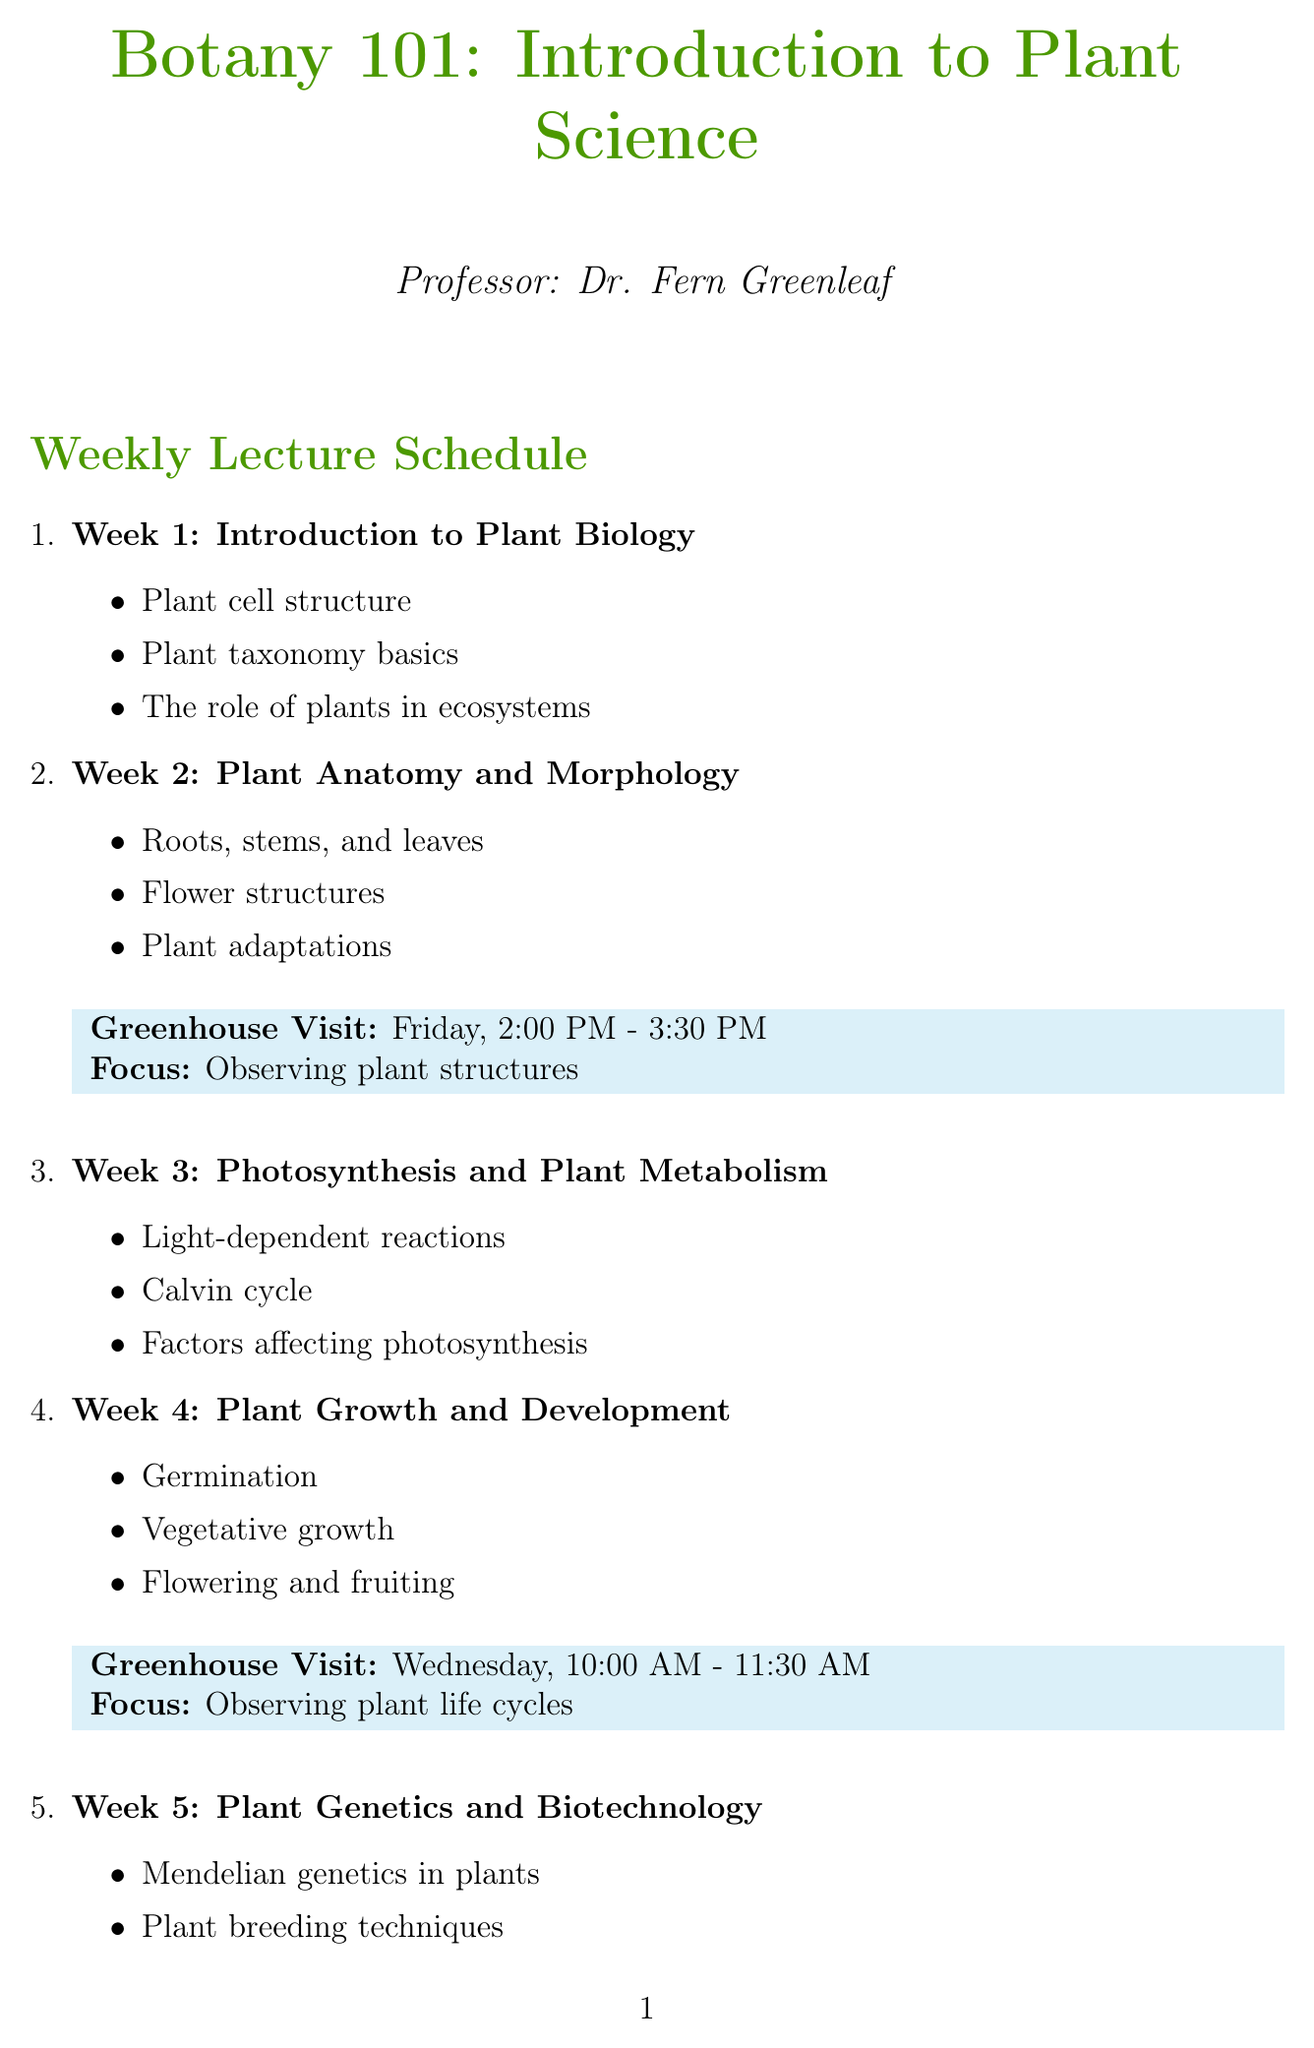What is the focus of the Week 2 greenhouse visit? The greenhouse visit in Week 2 focuses on observing plant structures as mentioned in the greenhouse visit details.
Answer: Observing plant structures When is the greenhouse visit for Week 4 scheduled? The greenhouse visit for Week 4 is scheduled for Wednesday from 10:00 AM to 11:30 AM as specified in the schedule.
Answer: Wednesday, 10:00 AM - 11:30 AM How many weeks are covered in the Botany 101 schedule? The schedule outlines a total of 8 weeks of lectures and greenhouse visits.
Answer: 8 Which topic in Week 6 covers interactions between plants and animals? The subtopic under Week 6 that addresses plant-animal interactions is part of the lecture on Plant Ecology and Conservation.
Answer: Plant-animal interactions What is the title of the course being offered? The document specifies the course being offered is "Botany 101: Introduction to Plant Science" as stated at the top of the document.
Answer: Botany 101: Introduction to Plant Science Which week includes a lecture on Plant Genetics and Biotechnology? Week 5 is dedicated to the topic of Plant Genetics and Biotechnology according to the weekly schedule.
Answer: Week 5 What unique plant is mentioned in the trivia section? The trivia section includes information about the corpse flower, which is known for its rare blooming.
Answer: corpse flower Which day is the greenhouse visit for Plant Diversity? The greenhouse visit for Plant Diversity is scheduled for Tuesday as indicated in the schedule.
Answer: Tuesday 